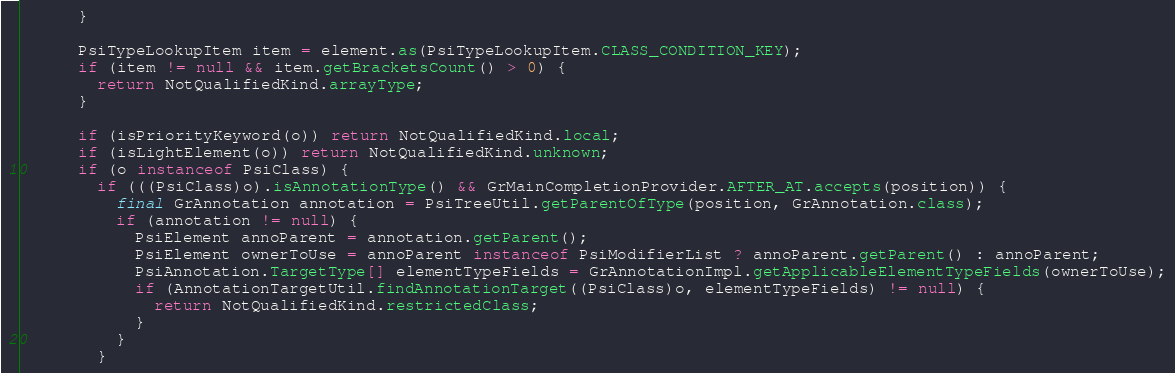<code> <loc_0><loc_0><loc_500><loc_500><_Java_>      }

      PsiTypeLookupItem item = element.as(PsiTypeLookupItem.CLASS_CONDITION_KEY);
      if (item != null && item.getBracketsCount() > 0) {
        return NotQualifiedKind.arrayType;
      }

      if (isPriorityKeyword(o)) return NotQualifiedKind.local;
      if (isLightElement(o)) return NotQualifiedKind.unknown;
      if (o instanceof PsiClass) {
        if (((PsiClass)o).isAnnotationType() && GrMainCompletionProvider.AFTER_AT.accepts(position)) {
          final GrAnnotation annotation = PsiTreeUtil.getParentOfType(position, GrAnnotation.class);
          if (annotation != null) {
            PsiElement annoParent = annotation.getParent();
            PsiElement ownerToUse = annoParent instanceof PsiModifierList ? annoParent.getParent() : annoParent;
            PsiAnnotation.TargetType[] elementTypeFields = GrAnnotationImpl.getApplicableElementTypeFields(ownerToUse);
            if (AnnotationTargetUtil.findAnnotationTarget((PsiClass)o, elementTypeFields) != null) {
              return NotQualifiedKind.restrictedClass;
            }
          }
        }</code> 